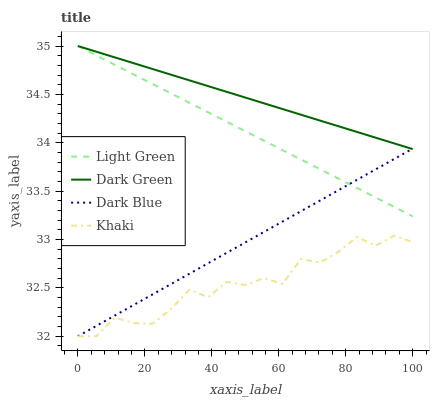Does Khaki have the minimum area under the curve?
Answer yes or no. Yes. Does Dark Green have the maximum area under the curve?
Answer yes or no. Yes. Does Light Green have the minimum area under the curve?
Answer yes or no. No. Does Light Green have the maximum area under the curve?
Answer yes or no. No. Is Dark Green the smoothest?
Answer yes or no. Yes. Is Khaki the roughest?
Answer yes or no. Yes. Is Light Green the smoothest?
Answer yes or no. No. Is Light Green the roughest?
Answer yes or no. No. Does Dark Blue have the lowest value?
Answer yes or no. Yes. Does Light Green have the lowest value?
Answer yes or no. No. Does Dark Green have the highest value?
Answer yes or no. Yes. Does Khaki have the highest value?
Answer yes or no. No. Is Khaki less than Light Green?
Answer yes or no. Yes. Is Light Green greater than Khaki?
Answer yes or no. Yes. Does Dark Blue intersect Light Green?
Answer yes or no. Yes. Is Dark Blue less than Light Green?
Answer yes or no. No. Is Dark Blue greater than Light Green?
Answer yes or no. No. Does Khaki intersect Light Green?
Answer yes or no. No. 